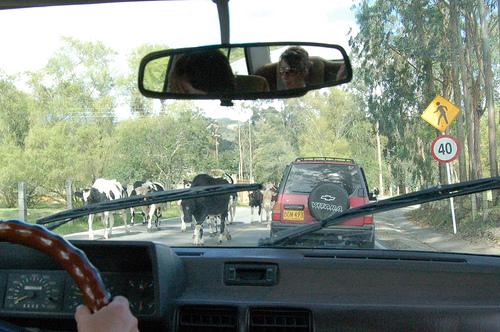What kind of animals can be seen?
Give a very brief answer. Cows. What is cast?
Concise answer only. Cows. What number is on the sign?
Write a very short answer. 40. What brand of vehicle is this?
Quick response, please. Chevy. Are there many people outside of the windows?
Quick response, please. No. 